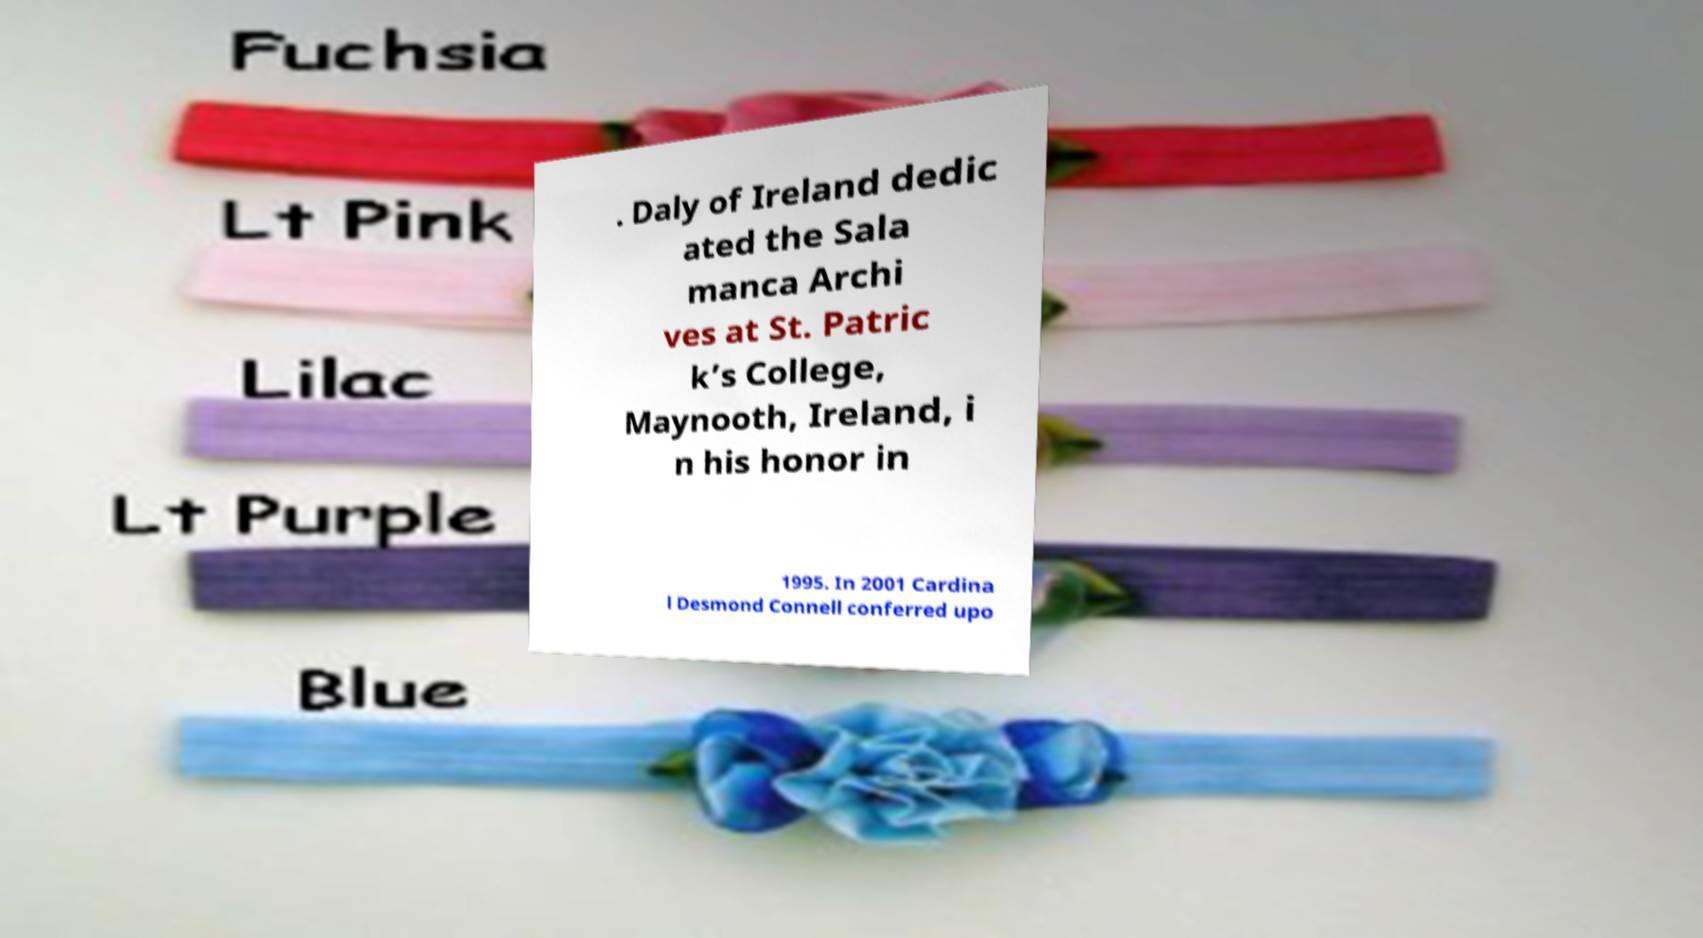What messages or text are displayed in this image? I need them in a readable, typed format. . Daly of Ireland dedic ated the Sala manca Archi ves at St. Patric k’s College, Maynooth, Ireland, i n his honor in 1995. In 2001 Cardina l Desmond Connell conferred upo 